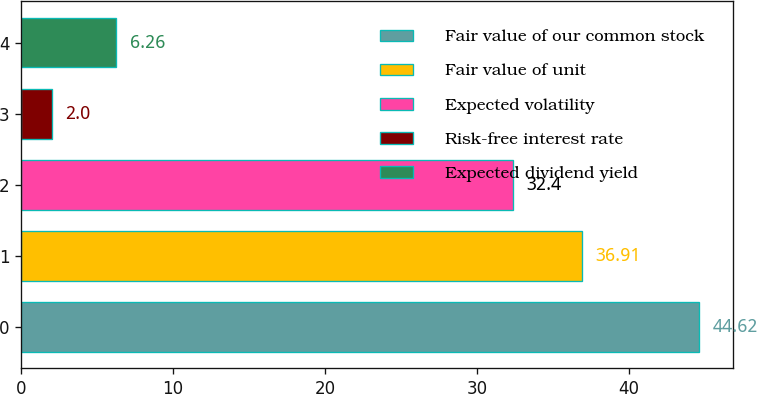<chart> <loc_0><loc_0><loc_500><loc_500><bar_chart><fcel>Fair value of our common stock<fcel>Fair value of unit<fcel>Expected volatility<fcel>Risk-free interest rate<fcel>Expected dividend yield<nl><fcel>44.62<fcel>36.91<fcel>32.4<fcel>2<fcel>6.26<nl></chart> 